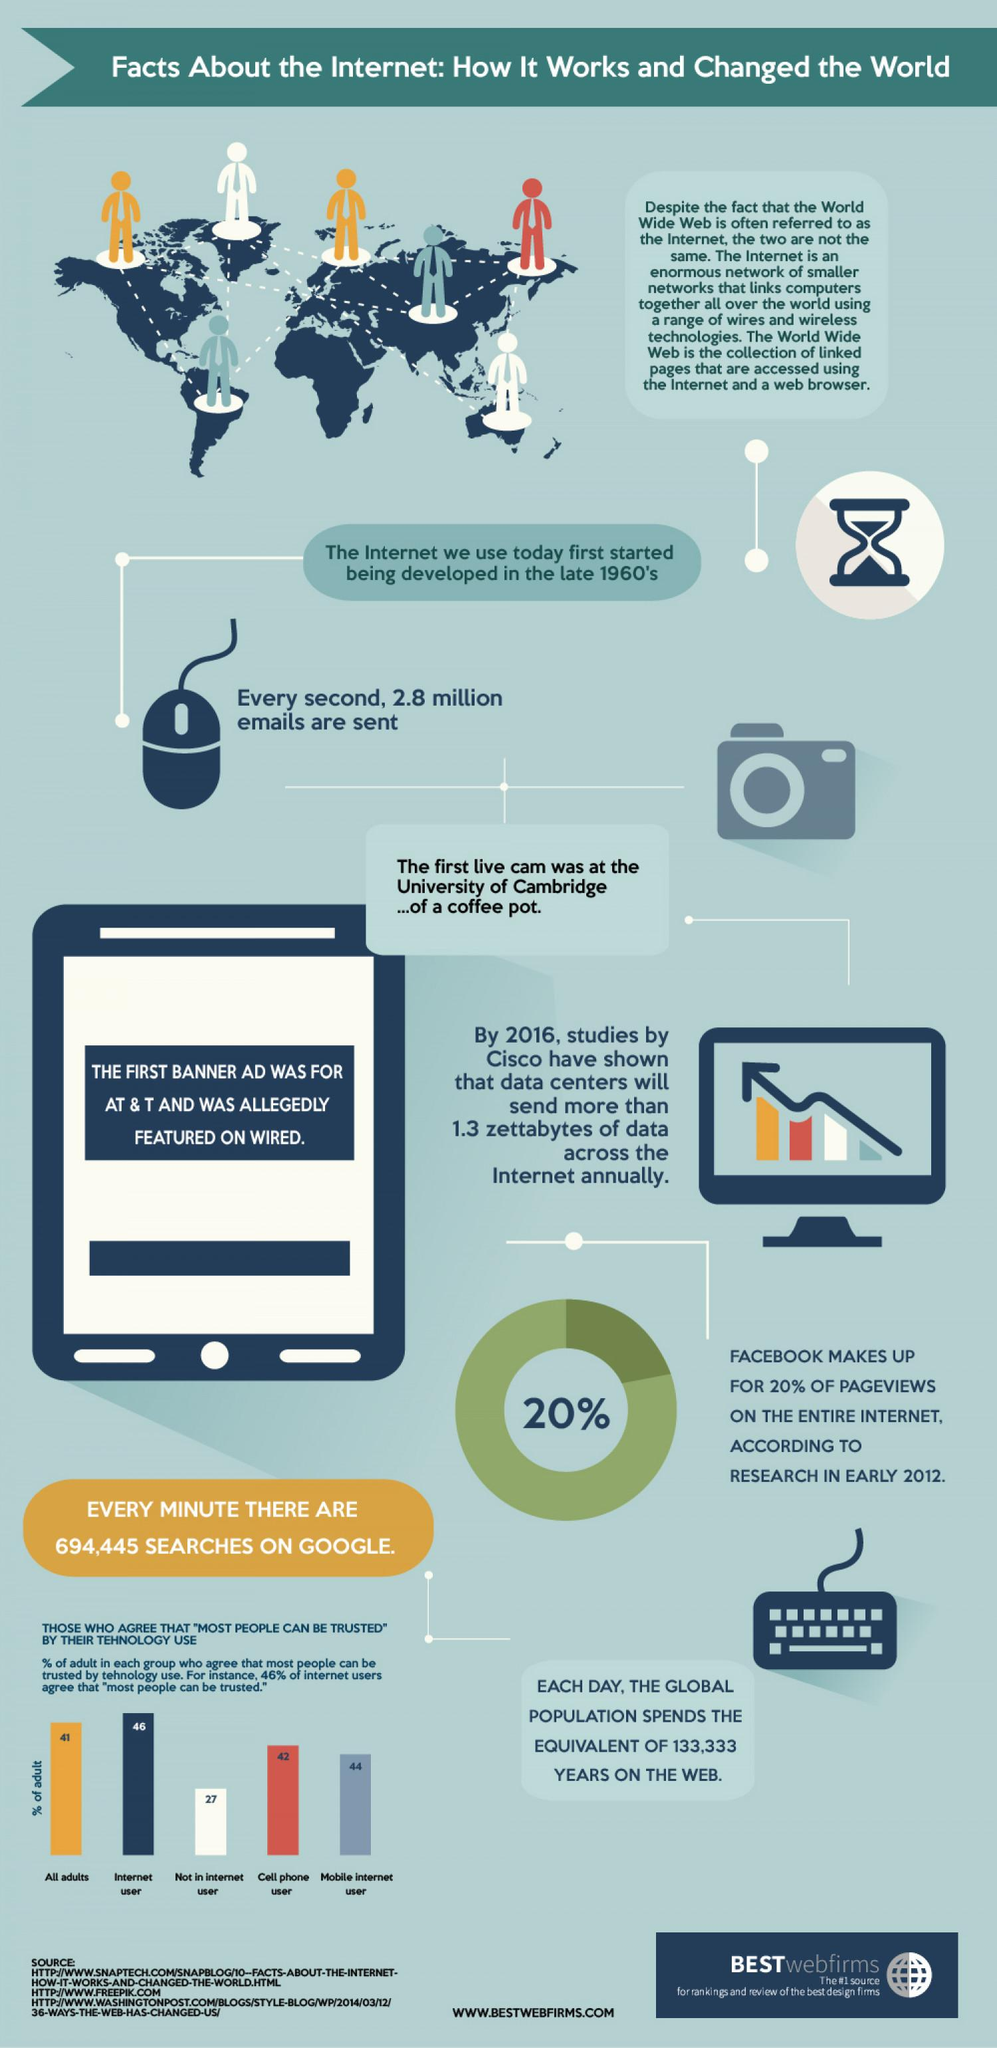Specify some key components in this picture. The number of individuals depicted in this infographic is 7. There are two cameras or mice featured in this infographic. 